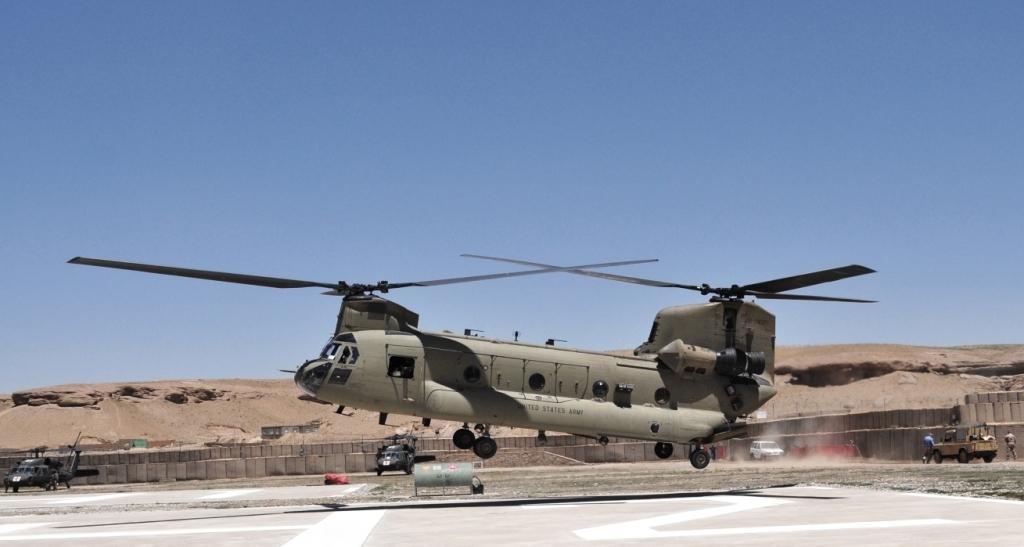In one or two sentences, can you explain what this image depicts? Here in this picture we can see an heavy lift helicopter flying in the air over there and on the ground we can see other helicopters and jeeps present over there and we can see people standing here and there and behind that we can see mountains present all over there. 